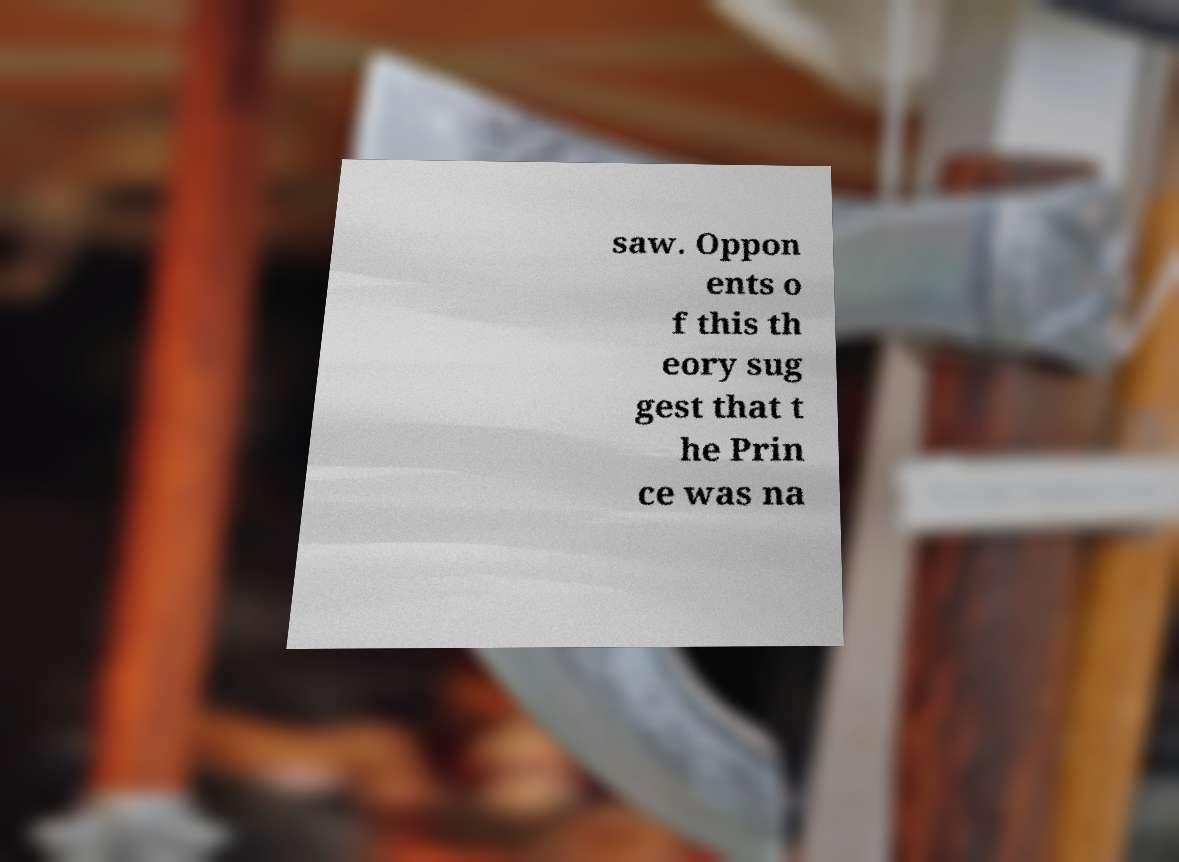Can you accurately transcribe the text from the provided image for me? saw. Oppon ents o f this th eory sug gest that t he Prin ce was na 